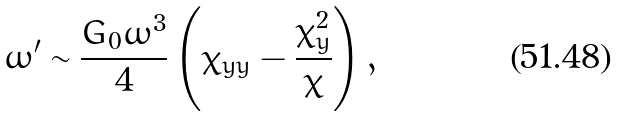<formula> <loc_0><loc_0><loc_500><loc_500>\omega ^ { \prime } \sim \frac { G _ { 0 } \omega ^ { 3 } } { 4 } \left ( \chi _ { y y } - \frac { \chi _ { y } ^ { 2 } } { \chi } \right ) ,</formula> 